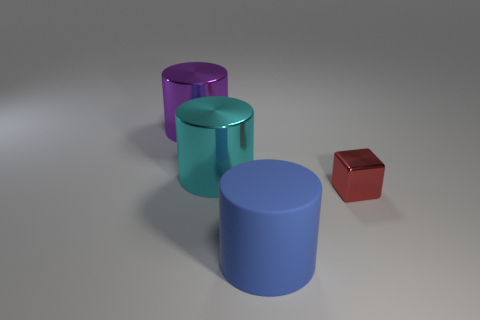Subtract all large shiny cylinders. How many cylinders are left? 1 Add 1 small rubber things. How many objects exist? 5 Subtract all purple balls. How many blue cylinders are left? 1 Subtract all big cyan objects. Subtract all gray matte objects. How many objects are left? 3 Add 4 big purple things. How many big purple things are left? 5 Add 2 blue matte objects. How many blue matte objects exist? 3 Subtract all cyan cylinders. How many cylinders are left? 2 Subtract 0 red spheres. How many objects are left? 4 Subtract all blocks. How many objects are left? 3 Subtract all brown cubes. Subtract all brown cylinders. How many cubes are left? 1 